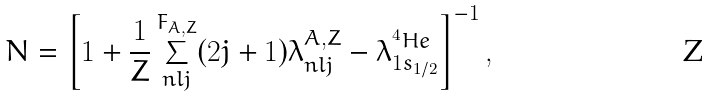<formula> <loc_0><loc_0><loc_500><loc_500>N = \left [ 1 + \frac { 1 } { Z } \sum _ { n l j } ^ { F _ { A , Z } } ( 2 j + 1 ) \lambda _ { n l j } ^ { A , Z } - \lambda _ { 1 s _ { 1 / 2 } } ^ { ^ { 4 } H e } \right ] ^ { - 1 } ,</formula> 